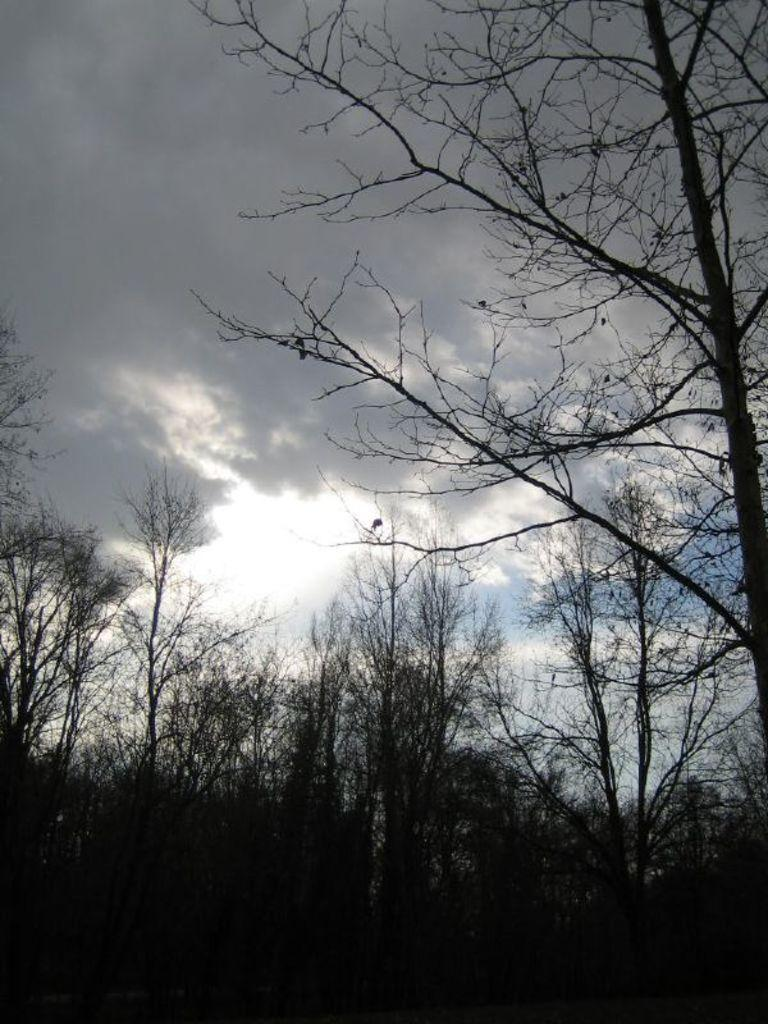What type of vegetation can be seen in the image? There are trees in the image. What part of the natural environment is visible in the image? The sky is visible in the background of the image. What type of road can be seen in the image? There is no road present in the image; it only features trees and the sky. Are there any police officers visible in the image? There are no police officers present in the image. 